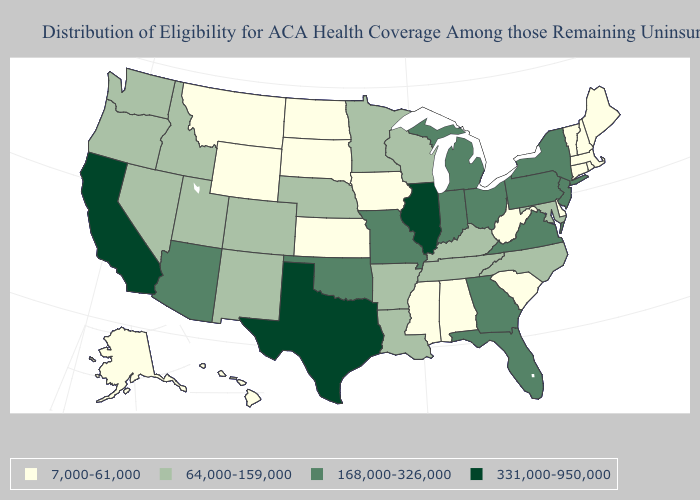What is the value of West Virginia?
Keep it brief. 7,000-61,000. Which states have the lowest value in the Northeast?
Concise answer only. Connecticut, Maine, Massachusetts, New Hampshire, Rhode Island, Vermont. What is the lowest value in states that border California?
Give a very brief answer. 64,000-159,000. Among the states that border Connecticut , does New York have the highest value?
Concise answer only. Yes. Which states hav the highest value in the South?
Keep it brief. Texas. Which states hav the highest value in the MidWest?
Concise answer only. Illinois. What is the value of Hawaii?
Concise answer only. 7,000-61,000. Does Illinois have the highest value in the USA?
Write a very short answer. Yes. How many symbols are there in the legend?
Answer briefly. 4. What is the value of West Virginia?
Give a very brief answer. 7,000-61,000. Does Hawaii have the lowest value in the West?
Answer briefly. Yes. Among the states that border South Carolina , which have the highest value?
Concise answer only. Georgia. Name the states that have a value in the range 331,000-950,000?
Keep it brief. California, Illinois, Texas. Which states have the highest value in the USA?
Be succinct. California, Illinois, Texas. What is the value of Louisiana?
Be succinct. 64,000-159,000. 